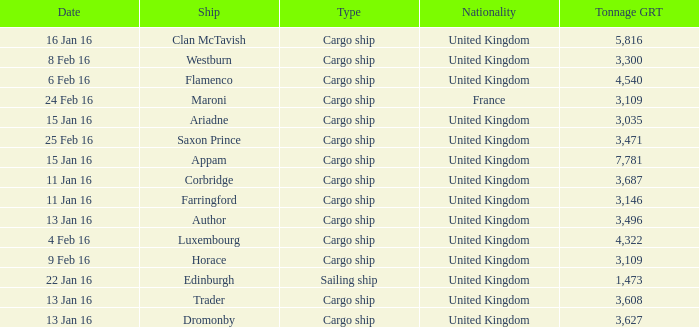What is the tonnage grt of the ship author? 3496.0. 